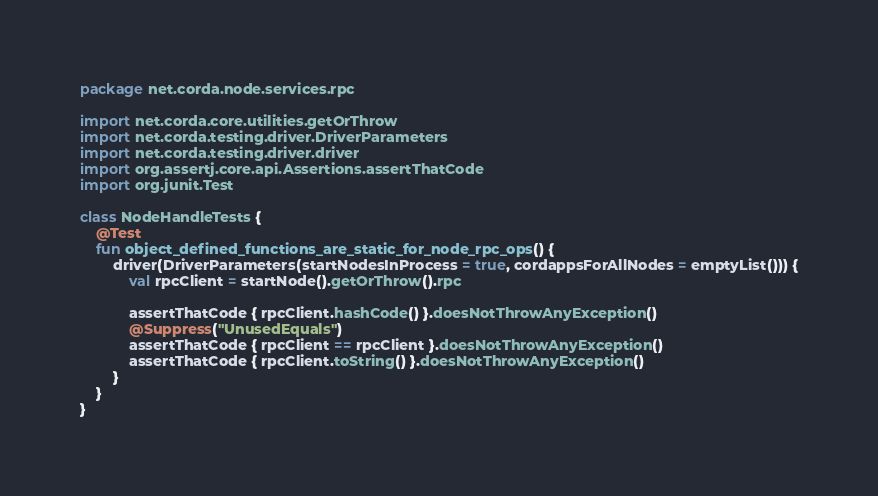Convert code to text. <code><loc_0><loc_0><loc_500><loc_500><_Kotlin_>package net.corda.node.services.rpc

import net.corda.core.utilities.getOrThrow
import net.corda.testing.driver.DriverParameters
import net.corda.testing.driver.driver
import org.assertj.core.api.Assertions.assertThatCode
import org.junit.Test

class NodeHandleTests {
    @Test
    fun object_defined_functions_are_static_for_node_rpc_ops() {
        driver(DriverParameters(startNodesInProcess = true, cordappsForAllNodes = emptyList())) {
            val rpcClient = startNode().getOrThrow().rpc

            assertThatCode { rpcClient.hashCode() }.doesNotThrowAnyException()
            @Suppress("UnusedEquals")
            assertThatCode { rpcClient == rpcClient }.doesNotThrowAnyException()
            assertThatCode { rpcClient.toString() }.doesNotThrowAnyException()
        }
    }
}</code> 